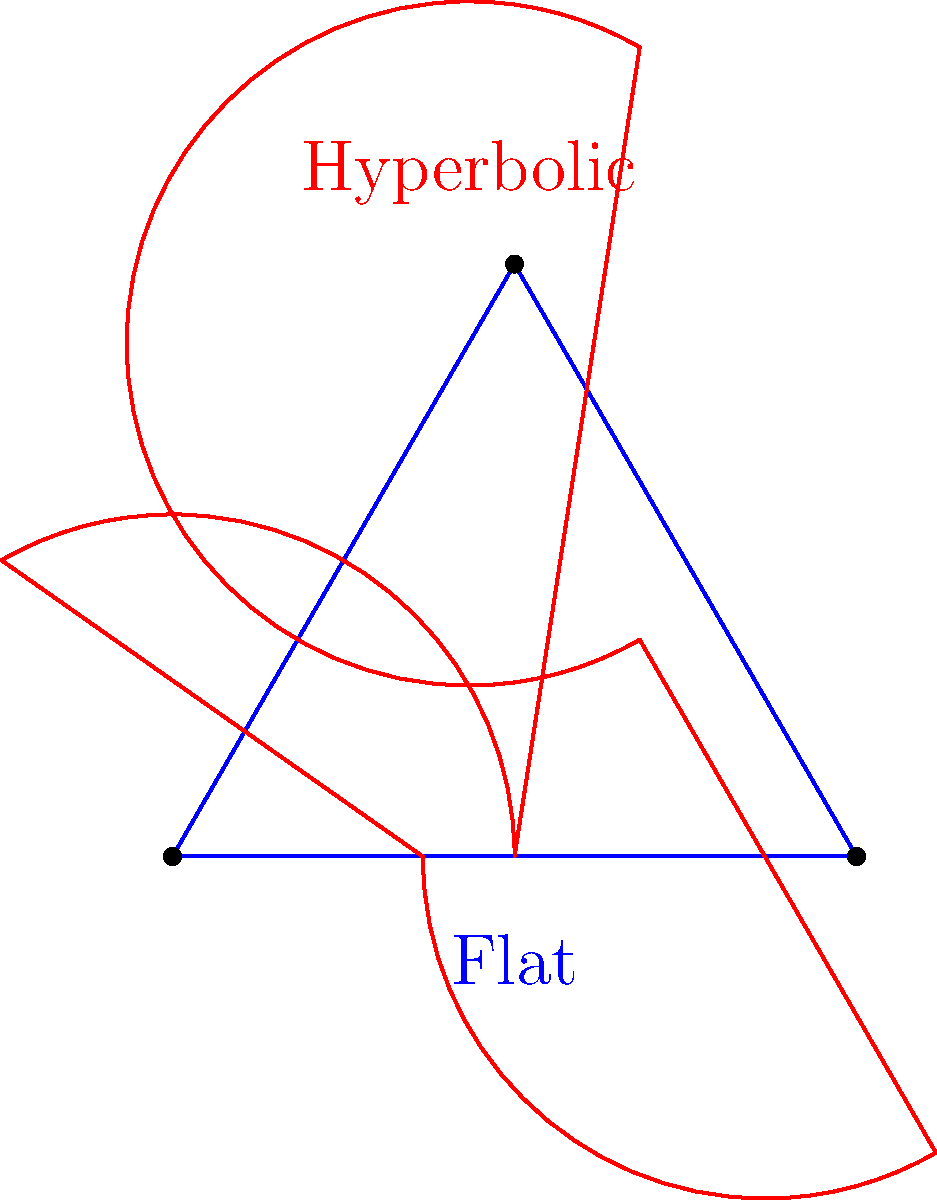While pouring a perfect pint of Guinness, you ponder the differences between flat and hyperbolic geometries. In the diagram, the blue triangle represents a triangle on a flat plane, while the red curve represents a triangle on a hyperbolic plane. If the sum of the interior angles of the blue triangle is 180°, what is the maximum possible sum of the interior angles of the red hyperbolic triangle? To solve this problem, let's follow these steps:

1. Recall that in Euclidean (flat) geometry, the sum of interior angles of a triangle is always 180°.

2. In hyperbolic geometry, the sum of interior angles of a triangle is always less than 180°. This is a fundamental property of hyperbolic space.

3. The difference between 180° and the sum of the angles in a hyperbolic triangle is called the defect. The defect is always positive in hyperbolic geometry.

4. The defect is proportional to the area of the triangle in hyperbolic space. As the area of the triangle approaches zero, the sum of its angles approaches 180°.

5. Therefore, the maximum possible sum of interior angles for a hyperbolic triangle would occur when the triangle is infinitesimally small, approaching a point.

6. In this limit case, the sum of angles in the hyperbolic triangle would approach, but never reach, 180°.

Thus, the maximum possible sum of the interior angles of the red hyperbolic triangle is arbitrarily close to, but always less than, 180°.
Answer: Less than 180° 